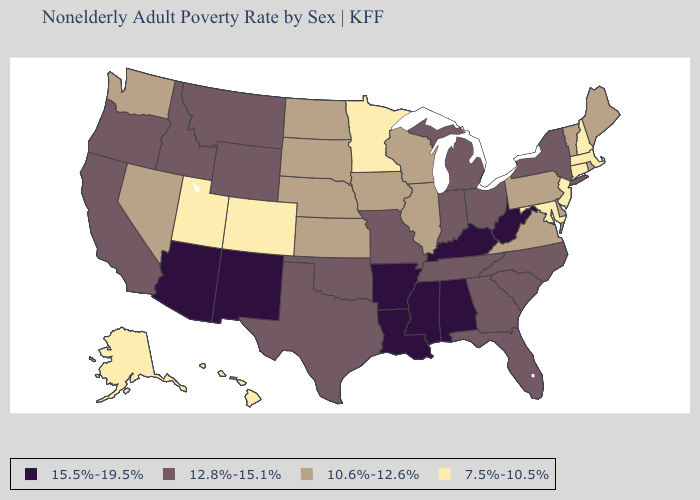Which states have the lowest value in the USA?
Write a very short answer. Alaska, Colorado, Connecticut, Hawaii, Maryland, Massachusetts, Minnesota, New Hampshire, New Jersey, Utah. What is the highest value in states that border North Carolina?
Short answer required. 12.8%-15.1%. Does Hawaii have the lowest value in the USA?
Keep it brief. Yes. Name the states that have a value in the range 15.5%-19.5%?
Answer briefly. Alabama, Arizona, Arkansas, Kentucky, Louisiana, Mississippi, New Mexico, West Virginia. Does Alabama have the same value as Arizona?
Write a very short answer. Yes. Does the first symbol in the legend represent the smallest category?
Give a very brief answer. No. Does Nevada have a lower value than Arizona?
Be succinct. Yes. What is the lowest value in the West?
Give a very brief answer. 7.5%-10.5%. What is the value of Minnesota?
Quick response, please. 7.5%-10.5%. Which states have the lowest value in the West?
Quick response, please. Alaska, Colorado, Hawaii, Utah. What is the highest value in the MidWest ?
Give a very brief answer. 12.8%-15.1%. How many symbols are there in the legend?
Write a very short answer. 4. How many symbols are there in the legend?
Concise answer only. 4. Does California have the lowest value in the West?
Concise answer only. No. Name the states that have a value in the range 10.6%-12.6%?
Concise answer only. Delaware, Illinois, Iowa, Kansas, Maine, Nebraska, Nevada, North Dakota, Pennsylvania, Rhode Island, South Dakota, Vermont, Virginia, Washington, Wisconsin. 